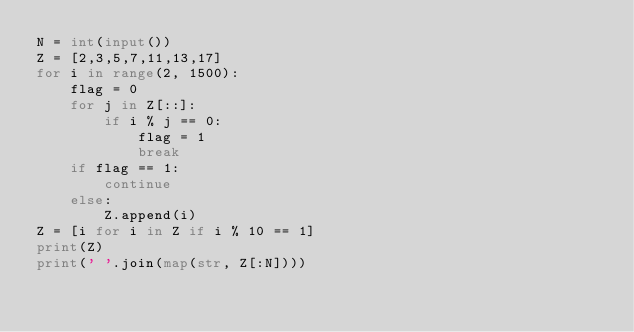Convert code to text. <code><loc_0><loc_0><loc_500><loc_500><_Python_>N = int(input())
Z = [2,3,5,7,11,13,17]
for i in range(2, 1500):
    flag = 0
    for j in Z[::]:
        if i % j == 0:
            flag = 1
            break
    if flag == 1:
        continue
    else:
        Z.append(i)
Z = [i for i in Z if i % 10 == 1]
print(Z)
print(' '.join(map(str, Z[:N])))</code> 